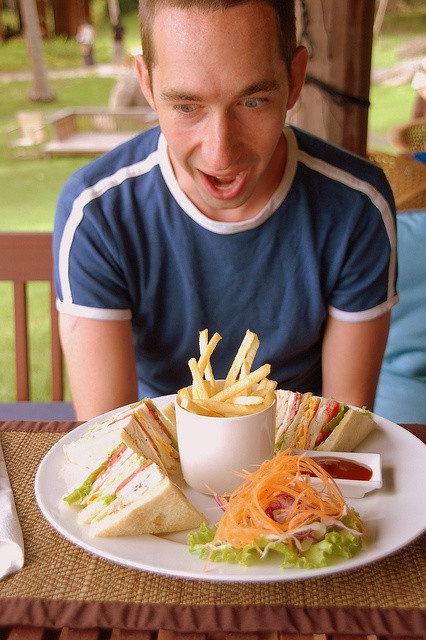Describe the objects in this image and their specific colors. I can see people in maroon, black, navy, and lightpink tones, dining table in maroon, brown, and gray tones, sandwich in maroon, lightgray, and tan tones, chair in maroon, brown, tan, and khaki tones, and cup in maroon, lightgray, tan, and gray tones in this image. 